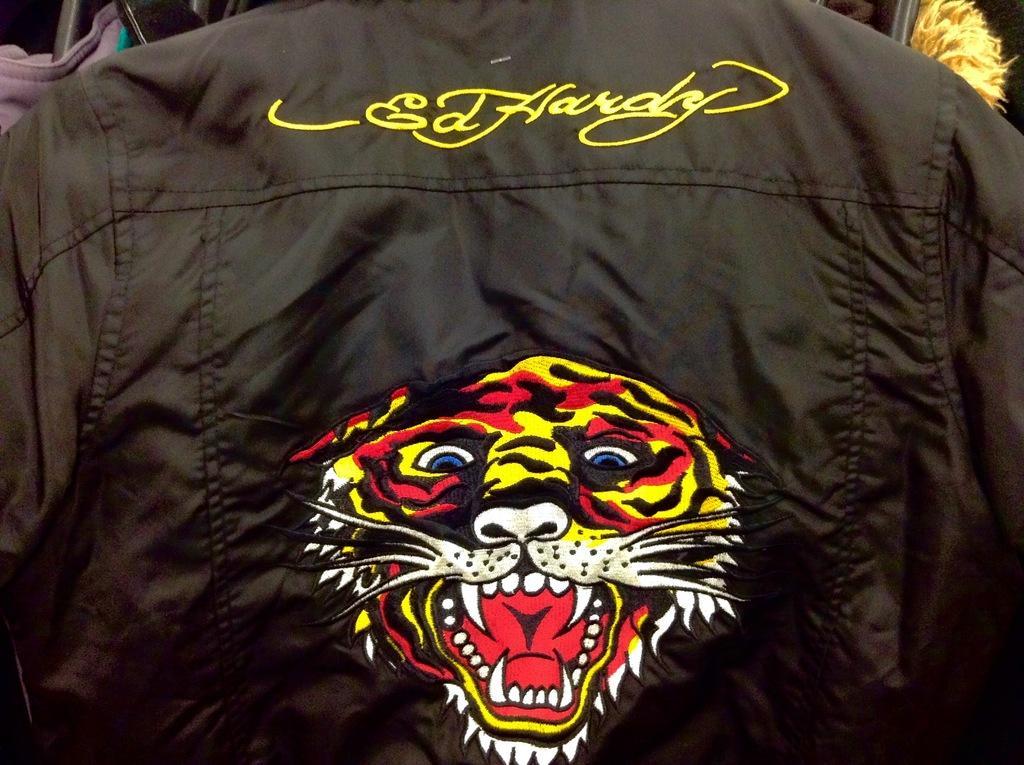Describe this image in one or two sentences. In this image we can see an embroidery on the shirt. 